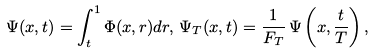Convert formula to latex. <formula><loc_0><loc_0><loc_500><loc_500>\Psi ( x , t ) = \int ^ { 1 } _ { t } \Phi ( x , r ) d r , \, \Psi _ { T } ( x , t ) = \frac { 1 } { F _ { T } } \, \Psi \left ( x , \frac { t } { T } \right ) ,</formula> 